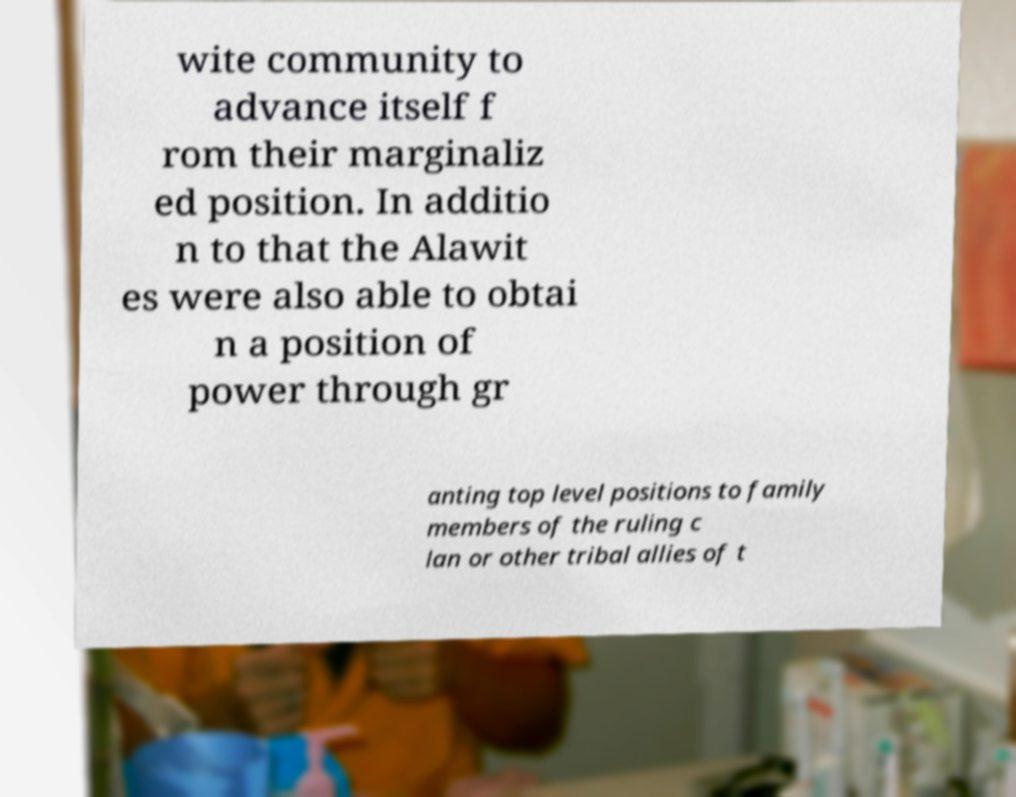What messages or text are displayed in this image? I need them in a readable, typed format. wite community to advance itself f rom their marginaliz ed position. In additio n to that the Alawit es were also able to obtai n a position of power through gr anting top level positions to family members of the ruling c lan or other tribal allies of t 